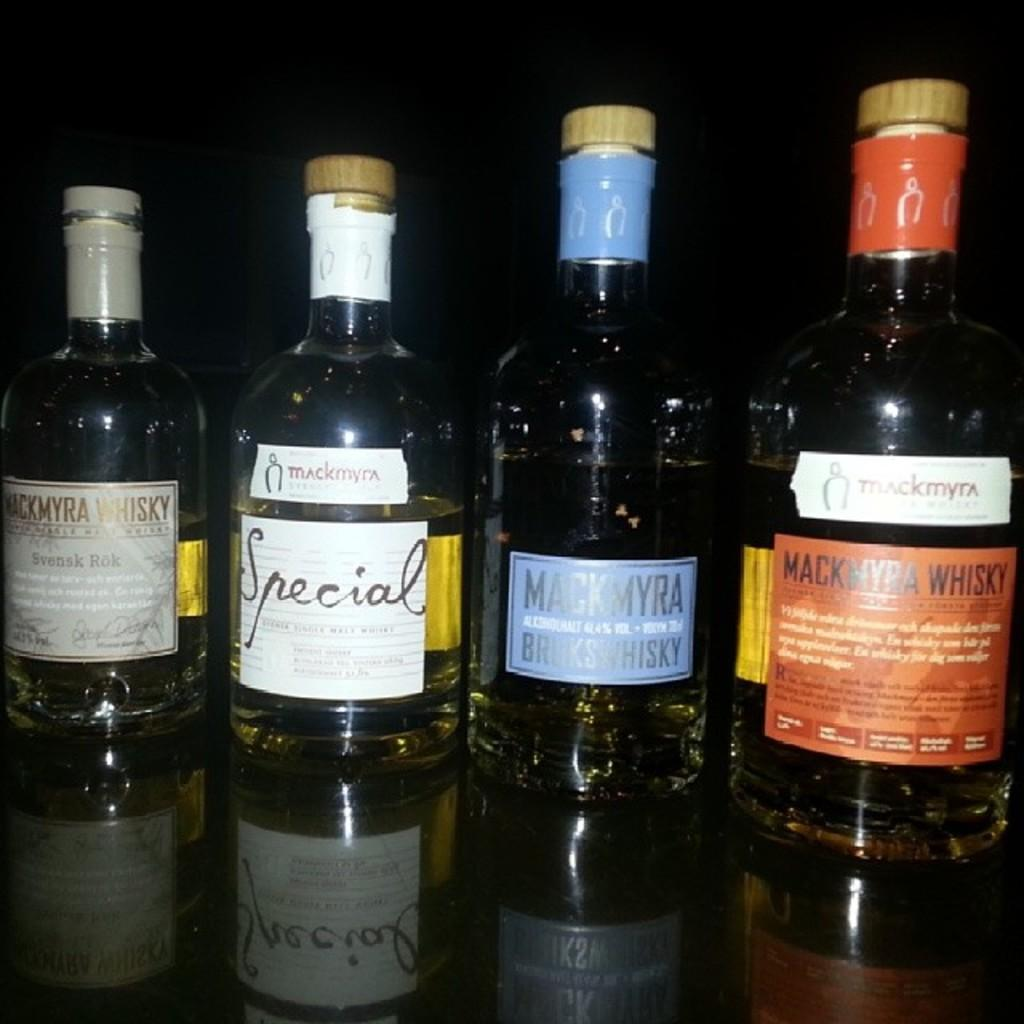<image>
Write a terse but informative summary of the picture. bottles of liquor lined up including Special and Mackmyra Whiskey 